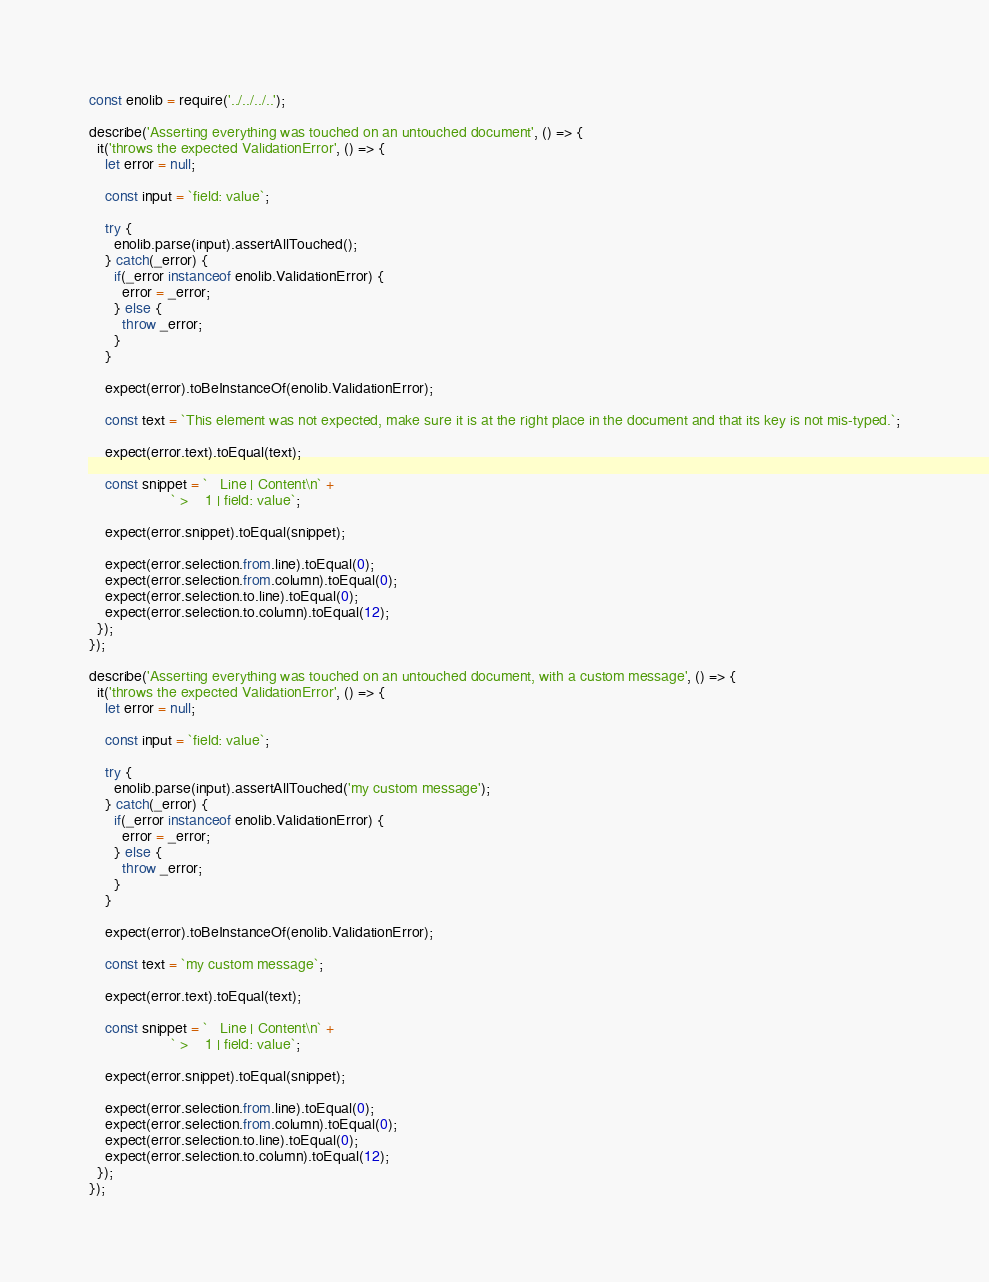<code> <loc_0><loc_0><loc_500><loc_500><_JavaScript_>const enolib = require('../../../..');

describe('Asserting everything was touched on an untouched document', () => {
  it('throws the expected ValidationError', () => {
    let error = null;

    const input = `field: value`;

    try {
      enolib.parse(input).assertAllTouched();
    } catch(_error) {
      if(_error instanceof enolib.ValidationError) {
        error = _error;
      } else {
        throw _error;
      }
    }

    expect(error).toBeInstanceOf(enolib.ValidationError);
    
    const text = `This element was not expected, make sure it is at the right place in the document and that its key is not mis-typed.`;
    
    expect(error.text).toEqual(text);
    
    const snippet = `   Line | Content\n` +
                    ` >    1 | field: value`;
    
    expect(error.snippet).toEqual(snippet);
    
    expect(error.selection.from.line).toEqual(0);
    expect(error.selection.from.column).toEqual(0);
    expect(error.selection.to.line).toEqual(0);
    expect(error.selection.to.column).toEqual(12);
  });
});

describe('Asserting everything was touched on an untouched document, with a custom message', () => {
  it('throws the expected ValidationError', () => {
    let error = null;

    const input = `field: value`;

    try {
      enolib.parse(input).assertAllTouched('my custom message');
    } catch(_error) {
      if(_error instanceof enolib.ValidationError) {
        error = _error;
      } else {
        throw _error;
      }
    }

    expect(error).toBeInstanceOf(enolib.ValidationError);
    
    const text = `my custom message`;
    
    expect(error.text).toEqual(text);
    
    const snippet = `   Line | Content\n` +
                    ` >    1 | field: value`;
    
    expect(error.snippet).toEqual(snippet);
    
    expect(error.selection.from.line).toEqual(0);
    expect(error.selection.from.column).toEqual(0);
    expect(error.selection.to.line).toEqual(0);
    expect(error.selection.to.column).toEqual(12);
  });
});</code> 